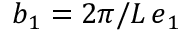<formula> <loc_0><loc_0><loc_500><loc_500>\boldsymbol b _ { 1 } = 2 \pi / L \, \boldsymbol e _ { 1 }</formula> 